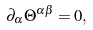<formula> <loc_0><loc_0><loc_500><loc_500>\partial _ { \alpha } \Theta ^ { \alpha \beta } = 0 ,</formula> 